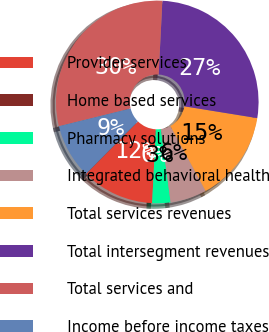<chart> <loc_0><loc_0><loc_500><loc_500><pie_chart><fcel>Provider services<fcel>Home based services<fcel>Pharmacy solutions<fcel>Integrated behavioral health<fcel>Total services revenues<fcel>Total intersegment revenues<fcel>Total services and<fcel>Income before income taxes<nl><fcel>11.62%<fcel>0.0%<fcel>2.91%<fcel>5.81%<fcel>14.53%<fcel>26.75%<fcel>29.66%<fcel>8.72%<nl></chart> 